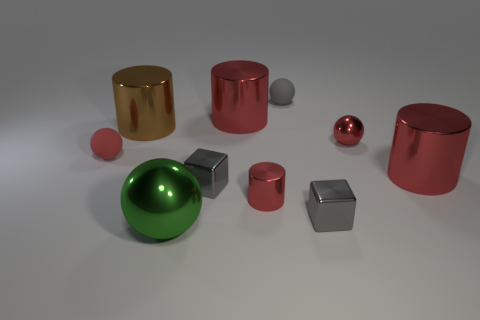What size is the object that is both behind the large brown cylinder and on the left side of the tiny gray ball?
Make the answer very short. Large. There is a green shiny object in front of the big red cylinder behind the red thing that is to the left of the big metallic ball; what size is it?
Your answer should be compact. Large. What size is the gray rubber sphere?
Provide a short and direct response. Small. There is a block right of the tiny gray rubber sphere that is right of the green ball; are there any gray matte spheres that are right of it?
Provide a short and direct response. No. How many small things are metal blocks or green shiny objects?
Give a very brief answer. 2. Are there any other things that have the same color as the large ball?
Your answer should be compact. No. There is a red thing to the left of the green object; does it have the same size as the large brown cylinder?
Provide a short and direct response. No. There is a metal ball in front of the big shiny cylinder that is in front of the tiny red thing left of the big green metal thing; what is its color?
Ensure brevity in your answer.  Green. What color is the tiny metallic ball?
Give a very brief answer. Red. Does the small cylinder have the same color as the small shiny ball?
Provide a short and direct response. Yes. 